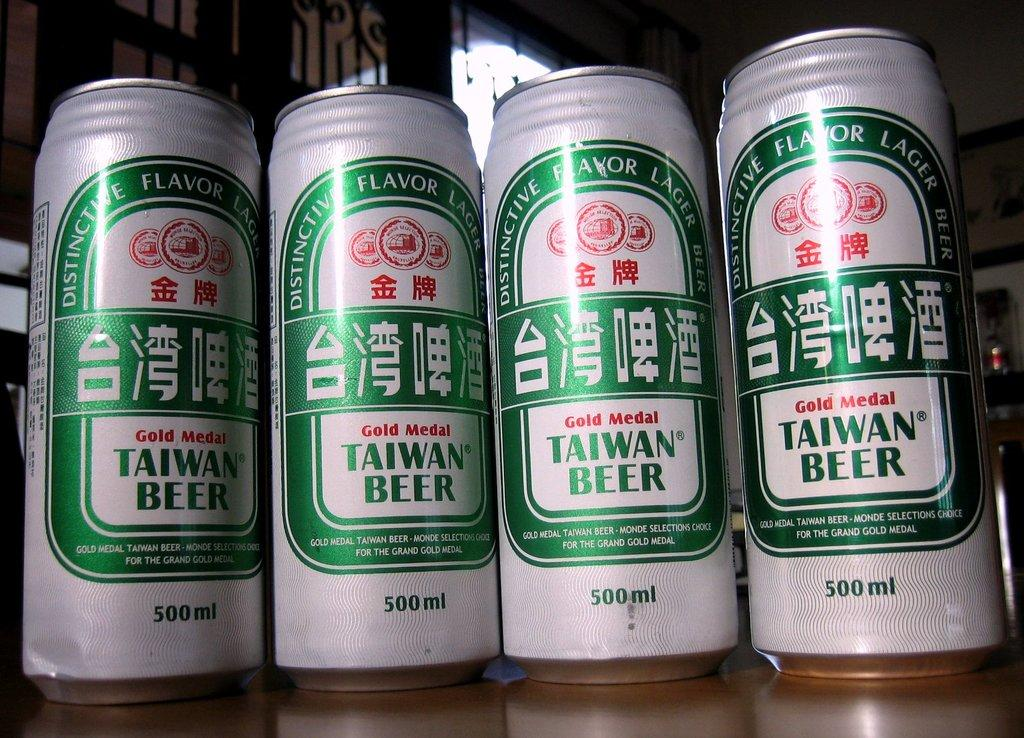Provide a one-sentence caption for the provided image. taiwan beer is lined up with three other taiwan beers. 